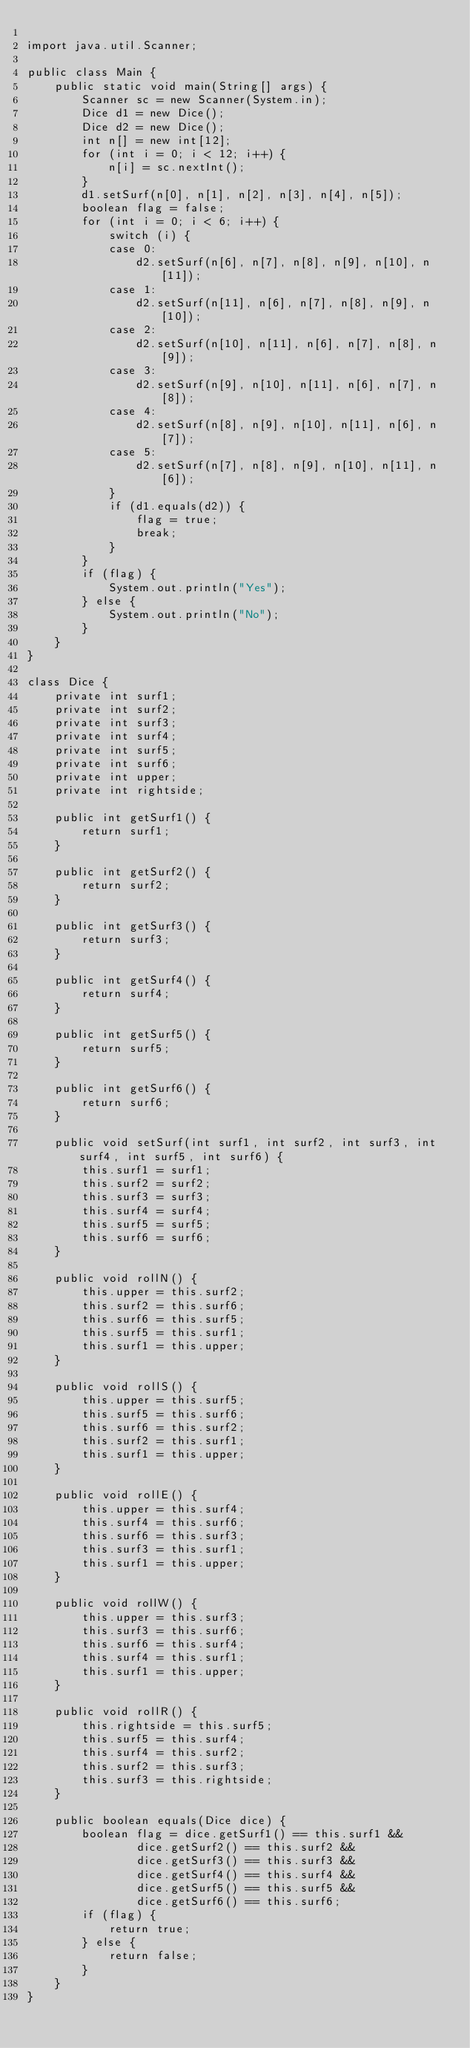Convert code to text. <code><loc_0><loc_0><loc_500><loc_500><_Java_>
import java.util.Scanner;

public class Main {
	public static void main(String[] args) {
		Scanner sc = new Scanner(System.in);
		Dice d1 = new Dice();
		Dice d2 = new Dice();
		int n[] = new int[12];
		for (int i = 0; i < 12; i++) {
			n[i] = sc.nextInt();
		}
		d1.setSurf(n[0], n[1], n[2], n[3], n[4], n[5]);
		boolean flag = false;
		for (int i = 0; i < 6; i++) {
			switch (i) {
			case 0:
				d2.setSurf(n[6], n[7], n[8], n[9], n[10], n[11]);
			case 1:
				d2.setSurf(n[11], n[6], n[7], n[8], n[9], n[10]);
			case 2:
				d2.setSurf(n[10], n[11], n[6], n[7], n[8], n[9]);
			case 3:
				d2.setSurf(n[9], n[10], n[11], n[6], n[7], n[8]);
			case 4:
				d2.setSurf(n[8], n[9], n[10], n[11], n[6], n[7]);
			case 5:
				d2.setSurf(n[7], n[8], n[9], n[10], n[11], n[6]);
			}
			if (d1.equals(d2)) {
				flag = true;
				break;
			}
		}
		if (flag) {
			System.out.println("Yes");
		} else {
			System.out.println("No");
		}
	}
}

class Dice {
	private int surf1;
	private int surf2;
	private int surf3;
	private int surf4;
	private int surf5;
	private int surf6;
	private int upper;
	private int rightside;

	public int getSurf1() {
		return surf1;
	}

	public int getSurf2() {
		return surf2;
	}

	public int getSurf3() {
		return surf3;
	}

	public int getSurf4() {
		return surf4;
	}

	public int getSurf5() {
		return surf5;
	}

	public int getSurf6() {
		return surf6;
	}

	public void setSurf(int surf1, int surf2, int surf3, int surf4, int surf5, int surf6) {
		this.surf1 = surf1;
		this.surf2 = surf2;
		this.surf3 = surf3;
		this.surf4 = surf4;
		this.surf5 = surf5;
		this.surf6 = surf6;
	}

	public void rollN() {
		this.upper = this.surf2;
		this.surf2 = this.surf6;
		this.surf6 = this.surf5;
		this.surf5 = this.surf1;
		this.surf1 = this.upper;
	}

	public void rollS() {
		this.upper = this.surf5;
		this.surf5 = this.surf6;
		this.surf6 = this.surf2;
		this.surf2 = this.surf1;
		this.surf1 = this.upper;
	}

	public void rollE() {
		this.upper = this.surf4;
		this.surf4 = this.surf6;
		this.surf6 = this.surf3;
		this.surf3 = this.surf1;
		this.surf1 = this.upper;
	}

	public void rollW() {
		this.upper = this.surf3;
		this.surf3 = this.surf6;
		this.surf6 = this.surf4;
		this.surf4 = this.surf1;
		this.surf1 = this.upper;
	}

	public void rollR() {
		this.rightside = this.surf5;
		this.surf5 = this.surf4;
		this.surf4 = this.surf2;
		this.surf2 = this.surf3;
		this.surf3 = this.rightside;
	}

	public boolean equals(Dice dice) {
		boolean flag = dice.getSurf1() == this.surf1 &&
				dice.getSurf2() == this.surf2 &&
				dice.getSurf3() == this.surf3 &&
				dice.getSurf4() == this.surf4 &&
				dice.getSurf5() == this.surf5 &&
				dice.getSurf6() == this.surf6;
		if (flag) {
			return true;
		} else {
			return false;
		}
	}
}
</code> 